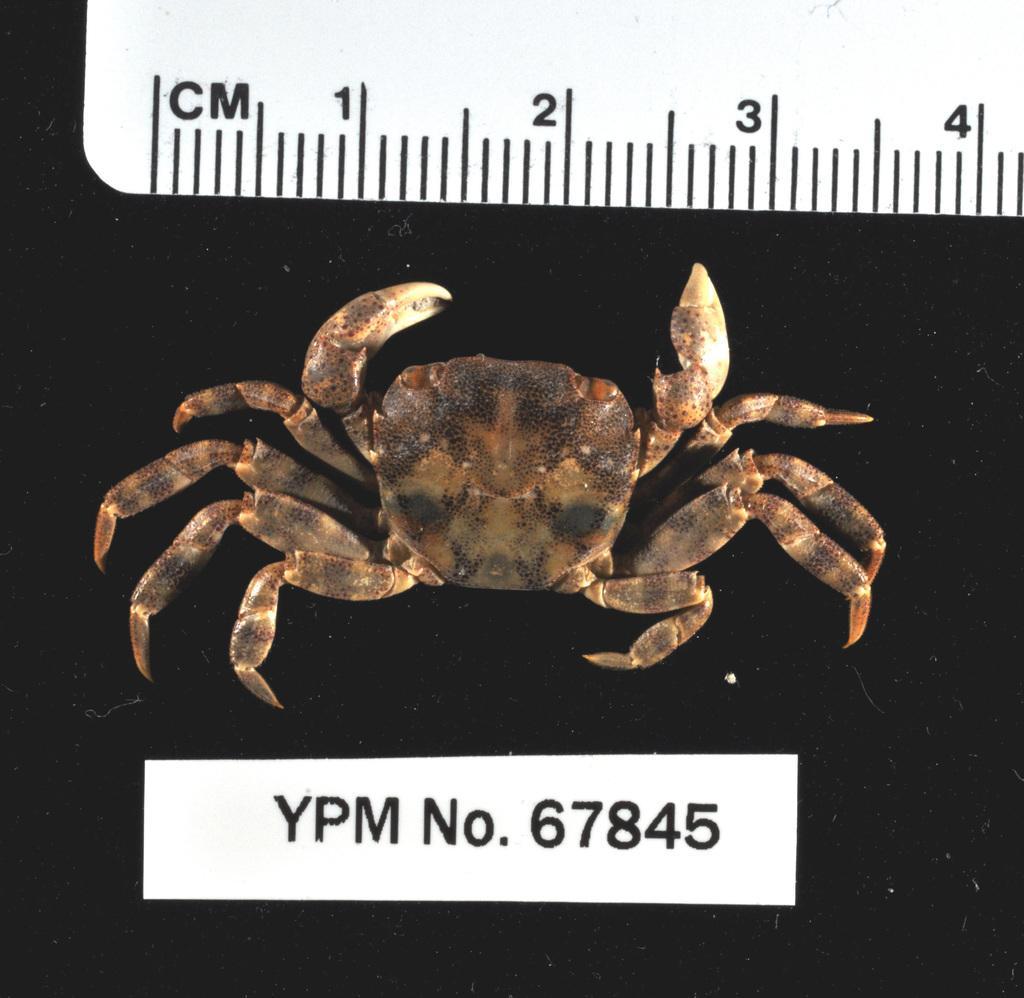Please provide a concise description of this image. In this image there is a crab. Top of the image there is a scale having measurement. Bottom of the image there is some text. 